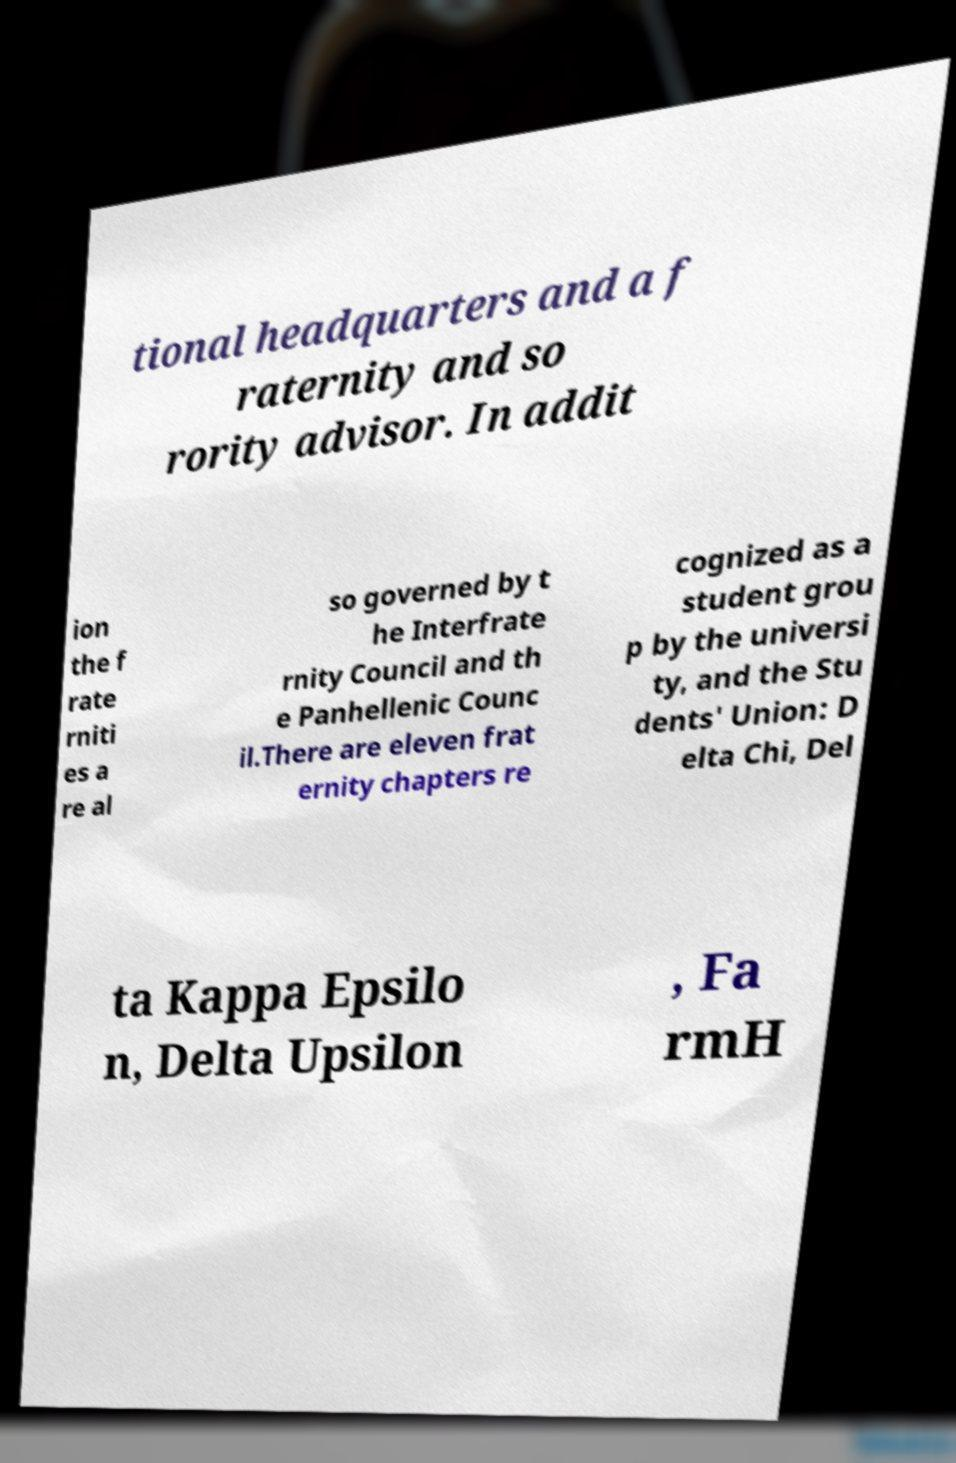There's text embedded in this image that I need extracted. Can you transcribe it verbatim? tional headquarters and a f raternity and so rority advisor. In addit ion the f rate rniti es a re al so governed by t he Interfrate rnity Council and th e Panhellenic Counc il.There are eleven frat ernity chapters re cognized as a student grou p by the universi ty, and the Stu dents' Union: D elta Chi, Del ta Kappa Epsilo n, Delta Upsilon , Fa rmH 